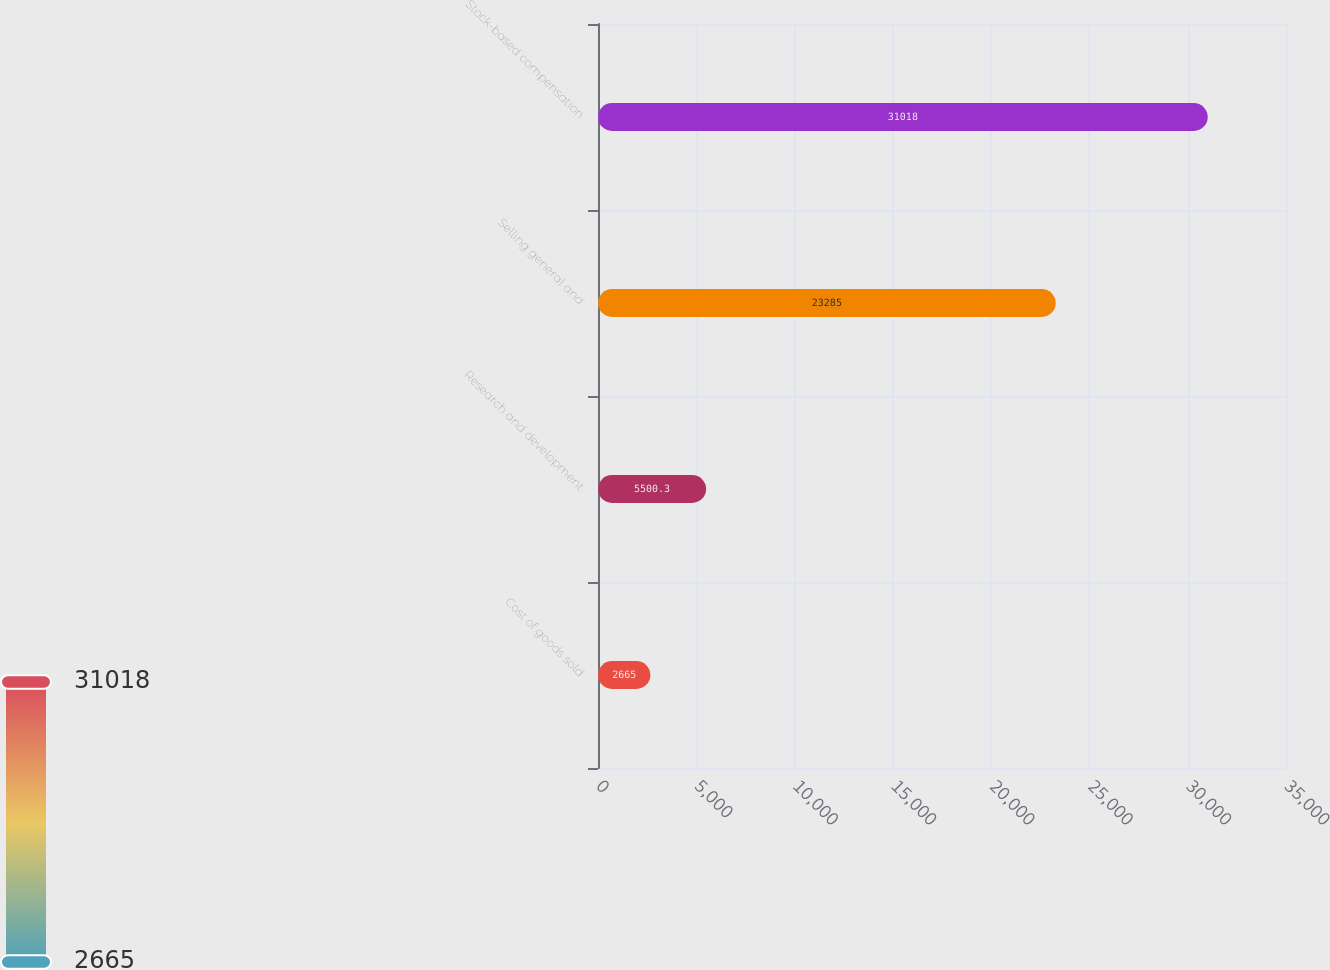<chart> <loc_0><loc_0><loc_500><loc_500><bar_chart><fcel>Cost of goods sold<fcel>Research and development<fcel>Selling general and<fcel>Stock-based compensation<nl><fcel>2665<fcel>5500.3<fcel>23285<fcel>31018<nl></chart> 